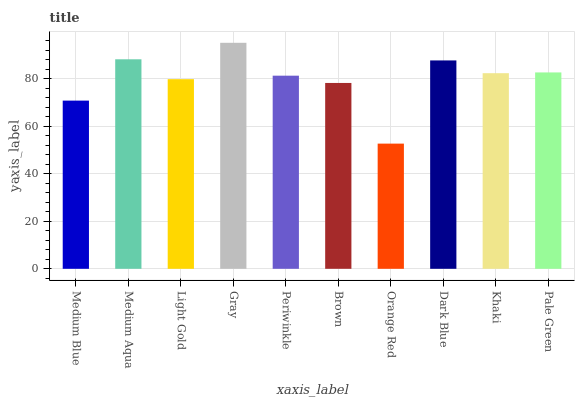Is Orange Red the minimum?
Answer yes or no. Yes. Is Gray the maximum?
Answer yes or no. Yes. Is Medium Aqua the minimum?
Answer yes or no. No. Is Medium Aqua the maximum?
Answer yes or no. No. Is Medium Aqua greater than Medium Blue?
Answer yes or no. Yes. Is Medium Blue less than Medium Aqua?
Answer yes or no. Yes. Is Medium Blue greater than Medium Aqua?
Answer yes or no. No. Is Medium Aqua less than Medium Blue?
Answer yes or no. No. Is Khaki the high median?
Answer yes or no. Yes. Is Periwinkle the low median?
Answer yes or no. Yes. Is Gray the high median?
Answer yes or no. No. Is Light Gold the low median?
Answer yes or no. No. 